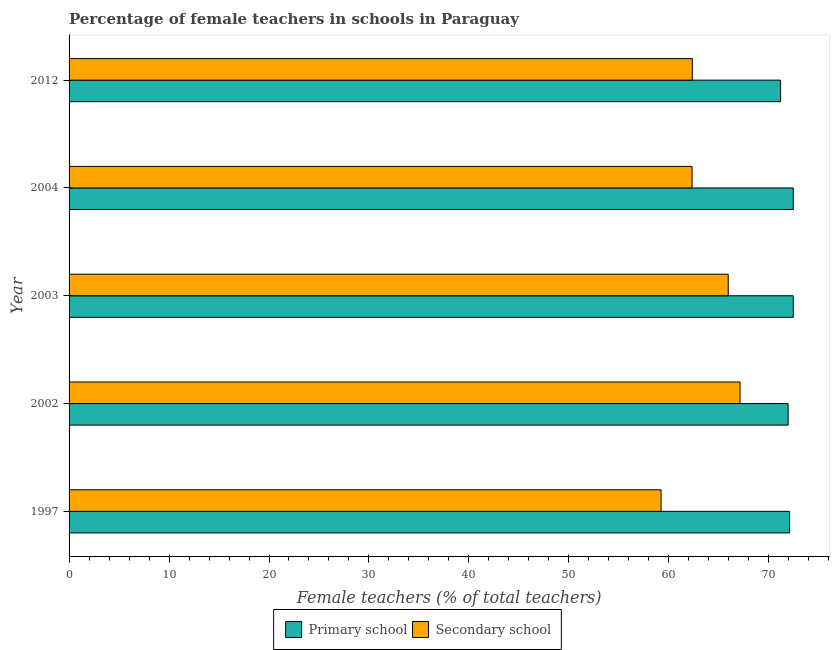How many groups of bars are there?
Your response must be concise. 5. Are the number of bars on each tick of the Y-axis equal?
Provide a succinct answer. Yes. How many bars are there on the 5th tick from the top?
Ensure brevity in your answer.  2. How many bars are there on the 1st tick from the bottom?
Make the answer very short. 2. What is the percentage of female teachers in secondary schools in 2004?
Offer a terse response. 62.32. Across all years, what is the maximum percentage of female teachers in primary schools?
Give a very brief answer. 72.45. Across all years, what is the minimum percentage of female teachers in secondary schools?
Give a very brief answer. 59.22. In which year was the percentage of female teachers in secondary schools minimum?
Your response must be concise. 1997. What is the total percentage of female teachers in primary schools in the graph?
Provide a short and direct response. 360.09. What is the difference between the percentage of female teachers in primary schools in 2002 and that in 2012?
Ensure brevity in your answer.  0.75. What is the difference between the percentage of female teachers in primary schools in 2012 and the percentage of female teachers in secondary schools in 2003?
Your answer should be very brief. 5.24. What is the average percentage of female teachers in secondary schools per year?
Keep it short and to the point. 63.39. In the year 1997, what is the difference between the percentage of female teachers in primary schools and percentage of female teachers in secondary schools?
Your response must be concise. 12.86. Is the percentage of female teachers in secondary schools in 1997 less than that in 2004?
Offer a terse response. Yes. Is the difference between the percentage of female teachers in secondary schools in 1997 and 2003 greater than the difference between the percentage of female teachers in primary schools in 1997 and 2003?
Make the answer very short. No. What is the difference between the highest and the second highest percentage of female teachers in primary schools?
Your answer should be very brief. 0. What is the difference between the highest and the lowest percentage of female teachers in primary schools?
Your response must be concise. 1.27. In how many years, is the percentage of female teachers in primary schools greater than the average percentage of female teachers in primary schools taken over all years?
Give a very brief answer. 3. Is the sum of the percentage of female teachers in primary schools in 1997 and 2012 greater than the maximum percentage of female teachers in secondary schools across all years?
Your answer should be compact. Yes. What does the 1st bar from the top in 2002 represents?
Offer a very short reply. Secondary school. What does the 1st bar from the bottom in 2003 represents?
Provide a short and direct response. Primary school. How many bars are there?
Your answer should be very brief. 10. How many years are there in the graph?
Give a very brief answer. 5. What is the difference between two consecutive major ticks on the X-axis?
Your answer should be compact. 10. Are the values on the major ticks of X-axis written in scientific E-notation?
Provide a succinct answer. No. What is the title of the graph?
Make the answer very short. Percentage of female teachers in schools in Paraguay. Does "Male entrants" appear as one of the legend labels in the graph?
Offer a terse response. No. What is the label or title of the X-axis?
Ensure brevity in your answer.  Female teachers (% of total teachers). What is the Female teachers (% of total teachers) in Primary school in 1997?
Ensure brevity in your answer.  72.08. What is the Female teachers (% of total teachers) in Secondary school in 1997?
Make the answer very short. 59.22. What is the Female teachers (% of total teachers) of Primary school in 2002?
Your answer should be compact. 71.93. What is the Female teachers (% of total teachers) of Secondary school in 2002?
Provide a short and direct response. 67.12. What is the Female teachers (% of total teachers) of Primary school in 2003?
Offer a terse response. 72.45. What is the Female teachers (% of total teachers) of Secondary school in 2003?
Your answer should be compact. 65.94. What is the Female teachers (% of total teachers) in Primary school in 2004?
Your answer should be very brief. 72.45. What is the Female teachers (% of total teachers) of Secondary school in 2004?
Provide a short and direct response. 62.32. What is the Female teachers (% of total teachers) of Primary school in 2012?
Give a very brief answer. 71.18. What is the Female teachers (% of total teachers) in Secondary school in 2012?
Offer a very short reply. 62.35. Across all years, what is the maximum Female teachers (% of total teachers) in Primary school?
Ensure brevity in your answer.  72.45. Across all years, what is the maximum Female teachers (% of total teachers) of Secondary school?
Offer a terse response. 67.12. Across all years, what is the minimum Female teachers (% of total teachers) of Primary school?
Your answer should be compact. 71.18. Across all years, what is the minimum Female teachers (% of total teachers) in Secondary school?
Ensure brevity in your answer.  59.22. What is the total Female teachers (% of total teachers) in Primary school in the graph?
Your answer should be very brief. 360.09. What is the total Female teachers (% of total teachers) in Secondary school in the graph?
Give a very brief answer. 316.96. What is the difference between the Female teachers (% of total teachers) in Primary school in 1997 and that in 2002?
Your answer should be very brief. 0.15. What is the difference between the Female teachers (% of total teachers) in Secondary school in 1997 and that in 2002?
Provide a short and direct response. -7.9. What is the difference between the Female teachers (% of total teachers) in Primary school in 1997 and that in 2003?
Your response must be concise. -0.36. What is the difference between the Female teachers (% of total teachers) in Secondary school in 1997 and that in 2003?
Make the answer very short. -6.72. What is the difference between the Female teachers (% of total teachers) in Primary school in 1997 and that in 2004?
Ensure brevity in your answer.  -0.36. What is the difference between the Female teachers (% of total teachers) in Secondary school in 1997 and that in 2004?
Provide a short and direct response. -3.1. What is the difference between the Female teachers (% of total teachers) of Primary school in 1997 and that in 2012?
Your answer should be compact. 0.9. What is the difference between the Female teachers (% of total teachers) of Secondary school in 1997 and that in 2012?
Provide a succinct answer. -3.13. What is the difference between the Female teachers (% of total teachers) in Primary school in 2002 and that in 2003?
Offer a terse response. -0.51. What is the difference between the Female teachers (% of total teachers) of Secondary school in 2002 and that in 2003?
Keep it short and to the point. 1.18. What is the difference between the Female teachers (% of total teachers) of Primary school in 2002 and that in 2004?
Offer a very short reply. -0.52. What is the difference between the Female teachers (% of total teachers) in Secondary school in 2002 and that in 2004?
Give a very brief answer. 4.8. What is the difference between the Female teachers (% of total teachers) in Primary school in 2002 and that in 2012?
Offer a terse response. 0.75. What is the difference between the Female teachers (% of total teachers) in Secondary school in 2002 and that in 2012?
Provide a succinct answer. 4.77. What is the difference between the Female teachers (% of total teachers) of Primary school in 2003 and that in 2004?
Give a very brief answer. -0. What is the difference between the Female teachers (% of total teachers) of Secondary school in 2003 and that in 2004?
Keep it short and to the point. 3.62. What is the difference between the Female teachers (% of total teachers) of Primary school in 2003 and that in 2012?
Your response must be concise. 1.27. What is the difference between the Female teachers (% of total teachers) in Secondary school in 2003 and that in 2012?
Ensure brevity in your answer.  3.59. What is the difference between the Female teachers (% of total teachers) of Primary school in 2004 and that in 2012?
Provide a succinct answer. 1.27. What is the difference between the Female teachers (% of total teachers) of Secondary school in 2004 and that in 2012?
Offer a terse response. -0.03. What is the difference between the Female teachers (% of total teachers) in Primary school in 1997 and the Female teachers (% of total teachers) in Secondary school in 2002?
Ensure brevity in your answer.  4.96. What is the difference between the Female teachers (% of total teachers) of Primary school in 1997 and the Female teachers (% of total teachers) of Secondary school in 2003?
Your response must be concise. 6.14. What is the difference between the Female teachers (% of total teachers) in Primary school in 1997 and the Female teachers (% of total teachers) in Secondary school in 2004?
Offer a very short reply. 9.76. What is the difference between the Female teachers (% of total teachers) of Primary school in 1997 and the Female teachers (% of total teachers) of Secondary school in 2012?
Offer a terse response. 9.73. What is the difference between the Female teachers (% of total teachers) of Primary school in 2002 and the Female teachers (% of total teachers) of Secondary school in 2003?
Make the answer very short. 5.99. What is the difference between the Female teachers (% of total teachers) in Primary school in 2002 and the Female teachers (% of total teachers) in Secondary school in 2004?
Provide a short and direct response. 9.61. What is the difference between the Female teachers (% of total teachers) of Primary school in 2002 and the Female teachers (% of total teachers) of Secondary school in 2012?
Ensure brevity in your answer.  9.58. What is the difference between the Female teachers (% of total teachers) of Primary school in 2003 and the Female teachers (% of total teachers) of Secondary school in 2004?
Your answer should be compact. 10.12. What is the difference between the Female teachers (% of total teachers) of Primary school in 2003 and the Female teachers (% of total teachers) of Secondary school in 2012?
Offer a terse response. 10.1. What is the difference between the Female teachers (% of total teachers) in Primary school in 2004 and the Female teachers (% of total teachers) in Secondary school in 2012?
Your answer should be very brief. 10.1. What is the average Female teachers (% of total teachers) in Primary school per year?
Your answer should be compact. 72.02. What is the average Female teachers (% of total teachers) of Secondary school per year?
Your answer should be very brief. 63.39. In the year 1997, what is the difference between the Female teachers (% of total teachers) in Primary school and Female teachers (% of total teachers) in Secondary school?
Offer a very short reply. 12.86. In the year 2002, what is the difference between the Female teachers (% of total teachers) of Primary school and Female teachers (% of total teachers) of Secondary school?
Your answer should be very brief. 4.81. In the year 2003, what is the difference between the Female teachers (% of total teachers) of Primary school and Female teachers (% of total teachers) of Secondary school?
Offer a terse response. 6.51. In the year 2004, what is the difference between the Female teachers (% of total teachers) of Primary school and Female teachers (% of total teachers) of Secondary school?
Offer a very short reply. 10.13. In the year 2012, what is the difference between the Female teachers (% of total teachers) in Primary school and Female teachers (% of total teachers) in Secondary school?
Provide a succinct answer. 8.83. What is the ratio of the Female teachers (% of total teachers) of Primary school in 1997 to that in 2002?
Offer a very short reply. 1. What is the ratio of the Female teachers (% of total teachers) in Secondary school in 1997 to that in 2002?
Your response must be concise. 0.88. What is the ratio of the Female teachers (% of total teachers) of Primary school in 1997 to that in 2003?
Offer a terse response. 0.99. What is the ratio of the Female teachers (% of total teachers) of Secondary school in 1997 to that in 2003?
Offer a terse response. 0.9. What is the ratio of the Female teachers (% of total teachers) of Primary school in 1997 to that in 2004?
Give a very brief answer. 0.99. What is the ratio of the Female teachers (% of total teachers) in Secondary school in 1997 to that in 2004?
Keep it short and to the point. 0.95. What is the ratio of the Female teachers (% of total teachers) in Primary school in 1997 to that in 2012?
Offer a terse response. 1.01. What is the ratio of the Female teachers (% of total teachers) in Secondary school in 1997 to that in 2012?
Your answer should be compact. 0.95. What is the ratio of the Female teachers (% of total teachers) of Primary school in 2002 to that in 2003?
Make the answer very short. 0.99. What is the ratio of the Female teachers (% of total teachers) of Secondary school in 2002 to that in 2003?
Ensure brevity in your answer.  1.02. What is the ratio of the Female teachers (% of total teachers) of Secondary school in 2002 to that in 2004?
Your answer should be compact. 1.08. What is the ratio of the Female teachers (% of total teachers) of Primary school in 2002 to that in 2012?
Give a very brief answer. 1.01. What is the ratio of the Female teachers (% of total teachers) in Secondary school in 2002 to that in 2012?
Give a very brief answer. 1.08. What is the ratio of the Female teachers (% of total teachers) of Primary school in 2003 to that in 2004?
Your answer should be very brief. 1. What is the ratio of the Female teachers (% of total teachers) of Secondary school in 2003 to that in 2004?
Keep it short and to the point. 1.06. What is the ratio of the Female teachers (% of total teachers) in Primary school in 2003 to that in 2012?
Make the answer very short. 1.02. What is the ratio of the Female teachers (% of total teachers) in Secondary school in 2003 to that in 2012?
Your answer should be very brief. 1.06. What is the ratio of the Female teachers (% of total teachers) in Primary school in 2004 to that in 2012?
Provide a succinct answer. 1.02. What is the difference between the highest and the second highest Female teachers (% of total teachers) of Secondary school?
Provide a succinct answer. 1.18. What is the difference between the highest and the lowest Female teachers (% of total teachers) of Primary school?
Your answer should be compact. 1.27. What is the difference between the highest and the lowest Female teachers (% of total teachers) in Secondary school?
Provide a succinct answer. 7.9. 